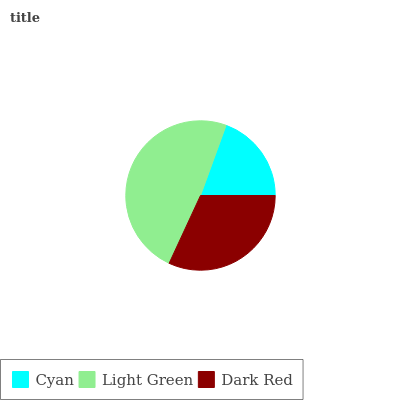Is Cyan the minimum?
Answer yes or no. Yes. Is Light Green the maximum?
Answer yes or no. Yes. Is Dark Red the minimum?
Answer yes or no. No. Is Dark Red the maximum?
Answer yes or no. No. Is Light Green greater than Dark Red?
Answer yes or no. Yes. Is Dark Red less than Light Green?
Answer yes or no. Yes. Is Dark Red greater than Light Green?
Answer yes or no. No. Is Light Green less than Dark Red?
Answer yes or no. No. Is Dark Red the high median?
Answer yes or no. Yes. Is Dark Red the low median?
Answer yes or no. Yes. Is Light Green the high median?
Answer yes or no. No. Is Cyan the low median?
Answer yes or no. No. 